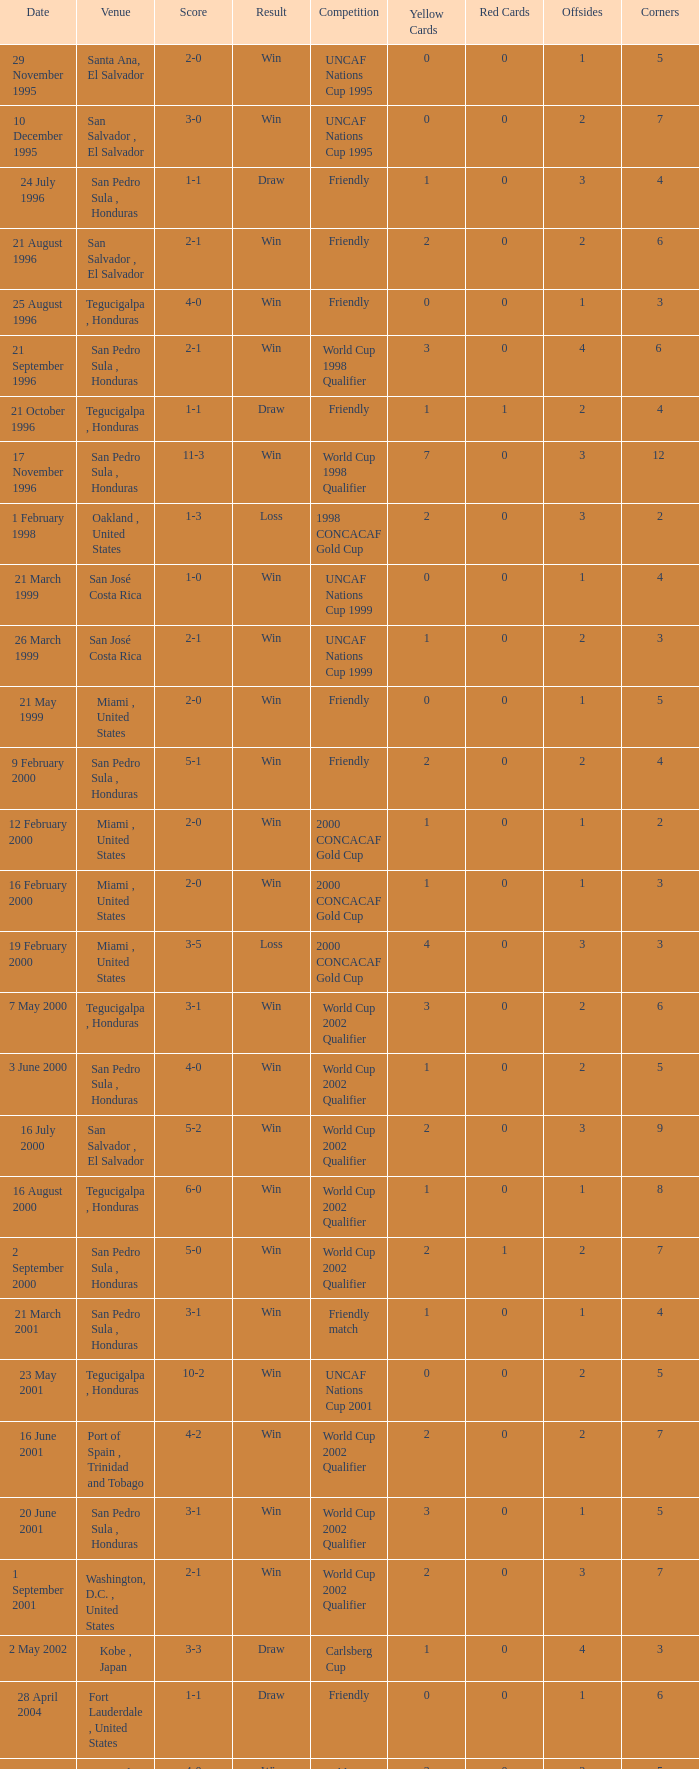Name the score for 7 may 2000 3-1. Help me parse the entirety of this table. {'header': ['Date', 'Venue', 'Score', 'Result', 'Competition', 'Yellow Cards', 'Red Cards', 'Offsides', 'Corners'], 'rows': [['29 November 1995', 'Santa Ana, El Salvador', '2-0', 'Win', 'UNCAF Nations Cup 1995', '0', '0', '1', '5'], ['10 December 1995', 'San Salvador , El Salvador', '3-0', 'Win', 'UNCAF Nations Cup 1995', '0', '0', '2', '7'], ['24 July 1996', 'San Pedro Sula , Honduras', '1-1', 'Draw', 'Friendly', '1', '0', '3', '4'], ['21 August 1996', 'San Salvador , El Salvador', '2-1', 'Win', 'Friendly', '2', '0', '2', '6'], ['25 August 1996', 'Tegucigalpa , Honduras', '4-0', 'Win', 'Friendly', '0', '0', '1', '3'], ['21 September 1996', 'San Pedro Sula , Honduras', '2-1', 'Win', 'World Cup 1998 Qualifier', '3', '0', '4', '6 '], ['21 October 1996', 'Tegucigalpa , Honduras', '1-1', 'Draw', 'Friendly', '1', '1', '2', '4'], ['17 November 1996', 'San Pedro Sula , Honduras', '11-3', 'Win', 'World Cup 1998 Qualifier', '7', '0', '3', '12 '], ['1 February 1998', 'Oakland , United States', '1-3', 'Loss', '1998 CONCACAF Gold Cup', '2', '0', '3', '2'], ['21 March 1999', 'San José Costa Rica', '1-0', 'Win', 'UNCAF Nations Cup 1999', '0', '0', '1', '4'], ['26 March 1999', 'San José Costa Rica', '2-1', 'Win', 'UNCAF Nations Cup 1999', '1', '0', '2', '3'], ['21 May 1999', 'Miami , United States', '2-0', 'Win', 'Friendly', '0', '0', '1', '5'], ['9 February 2000', 'San Pedro Sula , Honduras', '5-1', 'Win', 'Friendly', '2', '0', '2', '4'], ['12 February 2000', 'Miami , United States', '2-0', 'Win', '2000 CONCACAF Gold Cup', '1', '0', '1', '2'], ['16 February 2000', 'Miami , United States', '2-0', 'Win', '2000 CONCACAF Gold Cup', '1', '0', '1', '3'], ['19 February 2000', 'Miami , United States', '3-5', 'Loss', '2000 CONCACAF Gold Cup', '4', '0', '3', '3'], ['7 May 2000', 'Tegucigalpa , Honduras', '3-1', 'Win', 'World Cup 2002 Qualifier', '3', '0', '2', '6'], ['3 June 2000', 'San Pedro Sula , Honduras', '4-0', 'Win', 'World Cup 2002 Qualifier', '1', '0', '2', '5'], ['16 July 2000', 'San Salvador , El Salvador', '5-2', 'Win', 'World Cup 2002 Qualifier', '2', '0', '3', '9'], ['16 August 2000', 'Tegucigalpa , Honduras', '6-0', 'Win', 'World Cup 2002 Qualifier', '1', '0', '1', '8'], ['2 September 2000', 'San Pedro Sula , Honduras', '5-0', 'Win', 'World Cup 2002 Qualifier', '2', '1', '2', '7'], ['21 March 2001', 'San Pedro Sula , Honduras', '3-1', 'Win', 'Friendly match', '1', '0', '1', '4'], ['23 May 2001', 'Tegucigalpa , Honduras', '10-2', 'Win', 'UNCAF Nations Cup 2001', '0', '0', '2', '5'], ['16 June 2001', 'Port of Spain , Trinidad and Tobago', '4-2', 'Win', 'World Cup 2002 Qualifier', '2', '0', '2', '7'], ['20 June 2001', 'San Pedro Sula , Honduras', '3-1', 'Win', 'World Cup 2002 Qualifier', '3', '0', '1', '5'], ['1 September 2001', 'Washington, D.C. , United States', '2-1', 'Win', 'World Cup 2002 Qualifier', '2', '0', '3', '7'], ['2 May 2002', 'Kobe , Japan', '3-3', 'Draw', 'Carlsberg Cup', '1', '0', '4', '3'], ['28 April 2004', 'Fort Lauderdale , United States', '1-1', 'Draw', 'Friendly', '0', '0', '1', '6'], ['19 June 2004', 'San Pedro Sula , Honduras', '4-0', 'Win', 'World Cup 2006 Qualification', '3', '0', '2', '5'], ['19 April 2007', 'La Ceiba , Honduras', '1-3', 'Loss', 'Friendly', '2', '0', '2', '5'], ['25 May 2007', 'Mérida , Venezuela', '1-2', 'Loss', 'Friendly', '2', '0', '2', '4'], ['13 June 2007', 'Houston , United States', '5-0', 'Win', '2007 CONCACAF Gold Cup', '0', '0', '1', '6'], ['17 June 2007', 'Houston , United States', '1-2', 'Loss', '2007 CONCACAF Gold Cup', '1', '0', '3', '4'], ['18 January 2009', 'Miami , United States', '2-0', 'Win', 'Friendly', '0', '0', '0', '3'], ['26 January 2009', 'Tegucigalpa , Honduras', '2-0', 'Win', 'UNCAF Nations Cup 2009', '1', '0', '1', '6'], ['28 March 2009', 'Port of Spain , Trinidad and Tobago', '1-1', 'Draw', 'World Cup 2010 Qualification', '0', '0', '2', '4'], ['1 April 2009', 'San Pedro Sula , Honduras', '3-1', 'Win', 'World Cup 2010 Qualification', '2', '0', '1', '5'], ['10 June 2009', 'San Pedro Sula , Honduras', '1-0', 'Win', 'World Cup 2010 Qualification', '1', '0', '3', '7'], ['12 August 2009', 'San Pedro Sula , Honduras', '4-0', 'Win', 'World Cup 2010 Qualification', '0', '0', '1', '9'], ['5 September 2009', 'San Pedro Sula , Honduras', '4-1', 'Win', 'World Cup 2010 Qualification', '1', '0', '1', '6'], ['14 October 2009', 'San Salvador , El Salvador', '1-0', 'Win', 'World Cup 2010 Qualification', '2', '0', '2', '5'], ['23 January 2010', 'Carson , United States', '3-1', 'Win', 'Friendly', '1', '0', '1', '4']]} 